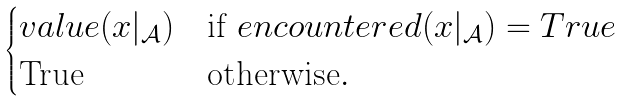<formula> <loc_0><loc_0><loc_500><loc_500>\begin{cases} v a l u e ( x | _ { \mathcal { A } } ) & \text {if} \ e n c o u n t e r e d ( x | _ { \mathcal { A } } ) = T r u e \\ \text {True} & \text {otherwise} . \end{cases}</formula> 